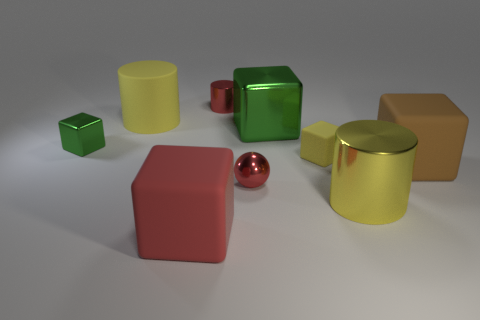How big is the red metal thing in front of the yellow matte cube on the right side of the large block on the left side of the tiny shiny cylinder? The red metal object appears to be a small geometric shape, possibly a cube, that is significantly smaller in scale compared to the large block on its left and the yellow matte cube. Its size can be described as compact and it seems to be about one-fourth the size of the yellow cube adjacent to it. 